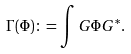Convert formula to latex. <formula><loc_0><loc_0><loc_500><loc_500>\Gamma ( \Phi ) \colon = \int G \Phi G ^ { \ast } .</formula> 